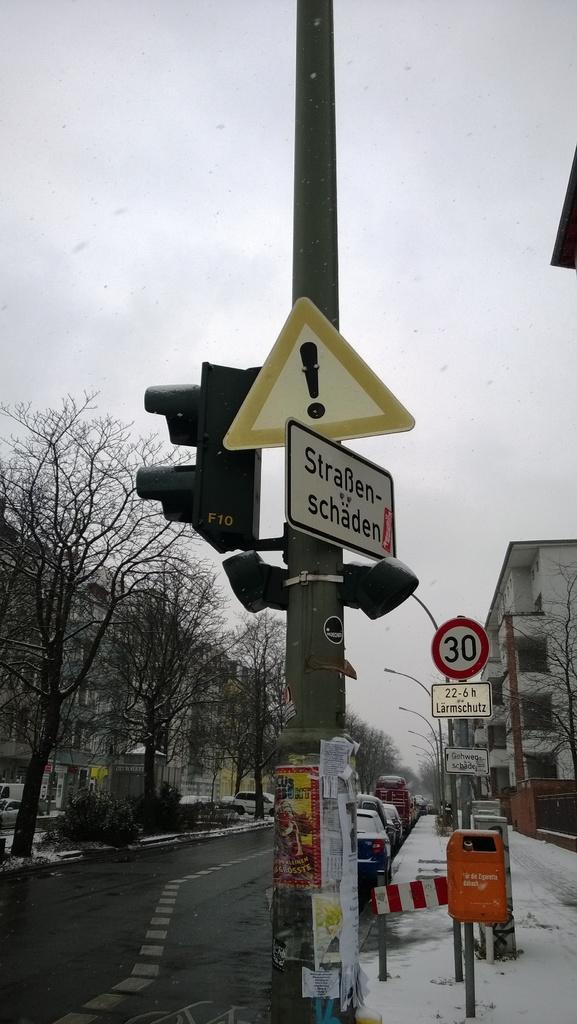In one or two sentences, can you explain what this image depicts? In this picture we can see there are poles and to the poles there are sign boards, directional boards and traffic signals. Behind the poles there are some vehicles parked on the road. On the left side of the vehicles there are trees, buildings and a cloudy sky. 